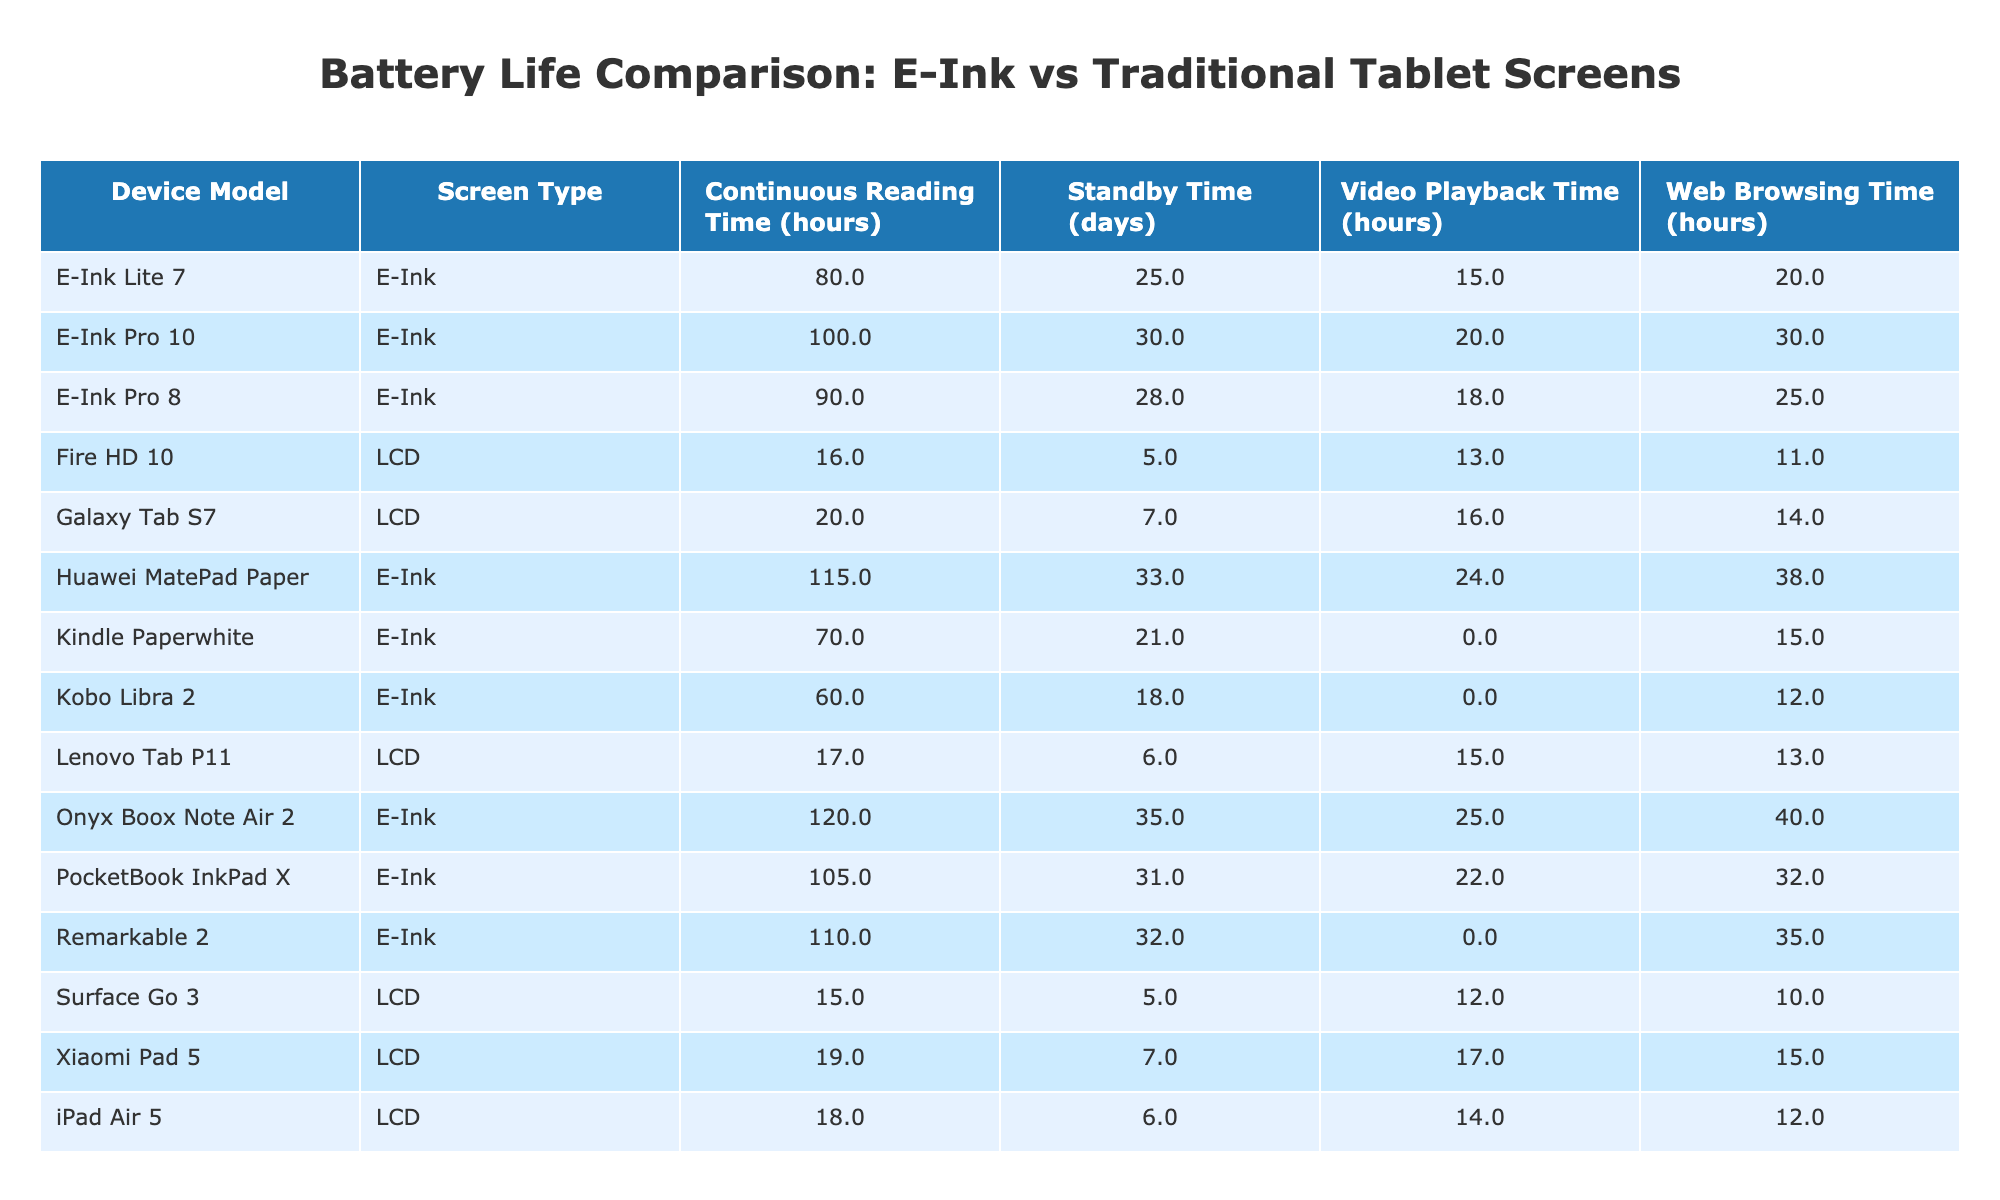What is the continuous reading time for the Onyx Boox Note Air 2? Referring to the table, under the column for continuous reading time, the Onyx Boox Note Air 2 is listed with a value of 120 hours.
Answer: 120 hours Which device has the longest battery standby time? The standby times are 30 for E-Ink Pro 10, 28 for E-Ink Pro 8, 25 for E-Ink Lite 7, 7 for Galaxy Tab S7, 6 for iPad Air 5, 21 for Kindle Paperwhite, 32 for Remarkable 2, 5 for Surface Go 3, 6 for Lenovo Tab P11, 5 for Fire HD 10, and 18 for Kobo Libra 2, while E-Ink Pro 10 has the longest standby time of 30 days.
Answer: E-Ink Pro 10 What is the average continuous reading time for all E-Ink devices? The continuous reading times for E-Ink devices are 100, 90, 80, 70, 110, 120, and 105 hours. Summing these values gives 775 hours. Dividing by the 7 devices provides an average of 775 / 7 ≈ 110.71 hours.
Answer: Approximately 110.71 hours Is the video playback time for the iPad Air 5 longer than that of the Galaxy Tab S7? The video playback time for the iPad Air 5 is noted as 14 hours, while that for the Galaxy Tab S7 is 16 hours. Since 14 is less than 16, the answer is false.
Answer: No Which screen type has greater average web browsing time? The web browsing times for E-Ink are 30, 25, 20, 15, 35, 40, 32 hours, totaling 197 hours for 7 devices which gives an average of 197 / 7 ≈ 28.14 hours. The LCD devices have browsing times of 14, 12, 10, 13, 15 hours totaling 64 hours across 5 devices, averaging 64 / 5 = 12.8 hours. Comparing the two, 28.14 hours for E-Ink is greater than 12.8 hours for LCD.
Answer: E-Ink What is the difference in battery capacity between the device with the highest capacity and the one with the lowest? The highest battery capacity is 8720 mAh (Xiaomi Pad 5) and the lowest is 1500 mAh (Kobo Libra 2). Subtracting gives: 8720 - 1500 = 7220 mAh, which indicates the difference in battery capacity.
Answer: 7220 mAh Do all E-Ink devices have a longer continuous reading time than all LCD devices? The continuous reading times for E-Ink devices are: 100, 90, 80, 70, 110, 120, 105 hours. For the LCD devices, they are: 20, 18, 15, 17, 19 hours. The maximum for LCD is 20 hours, while the minimum for E-Ink is 70 hours, confirming that all E-Ink devices surpass the maximum LCD reading time.
Answer: Yes Which E-Ink device has the best video playback time? Among the E-Ink devices, the video playback times are: 20, 18, N/A (for Kindle Paperwhite), N/A, 25, 24, and 22 hours. Ignoring the N/A, the highest value is 25 hours for the Onyx Boox Note Air 2.
Answer: 25 hours 